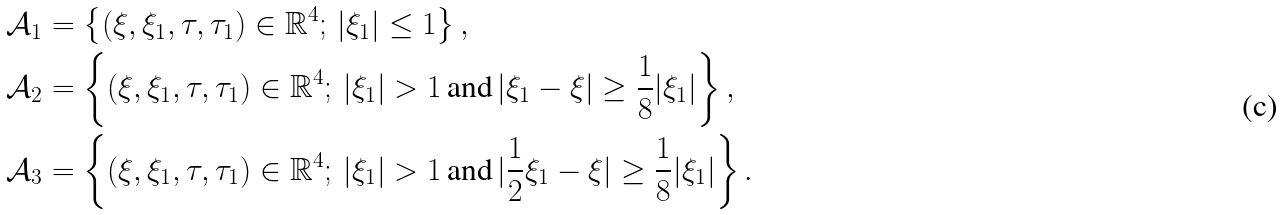<formula> <loc_0><loc_0><loc_500><loc_500>& { \mathcal { A } } _ { 1 } = \left \{ ( \xi , \xi _ { 1 } , \tau , \tau _ { 1 } ) \in { \mathbb { R } } ^ { 4 } ; \, | \xi _ { 1 } | \leq 1 \right \} , \\ & { \mathcal { A } } _ { 2 } = \left \{ ( \xi , \xi _ { 1 } , \tau , \tau _ { 1 } ) \in { \mathbb { R } } ^ { 4 } ; \, | \xi _ { 1 } | > 1 \, \text {and} \, | \xi _ { 1 } - \xi | \geq \frac { 1 } { 8 } | \xi _ { 1 } | \right \} , \\ & { \mathcal { A } } _ { 3 } = \left \{ ( \xi , \xi _ { 1 } , \tau , \tau _ { 1 } ) \in { \mathbb { R } } ^ { 4 } ; \, | \xi _ { 1 } | > 1 \, \text {and} \, | \frac { 1 } { 2 } \xi _ { 1 } - \xi | \geq \frac { 1 } { 8 } | \xi _ { 1 } | \right \} .</formula> 